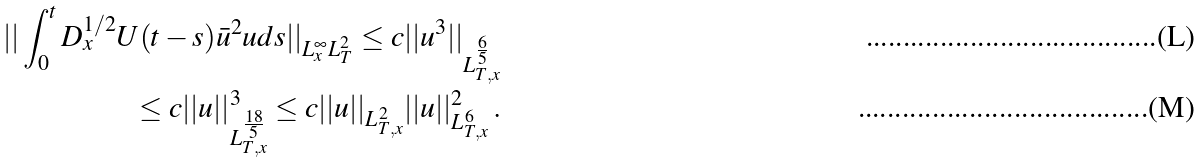<formula> <loc_0><loc_0><loc_500><loc_500>| | \int _ { 0 } ^ { t } D _ { x } ^ { 1 / 2 } U ( t - s ) \bar { u } ^ { 2 } u d s | | _ { L ^ { \infty } _ { x } L ^ { 2 } _ { T } } \leq c | | u ^ { 3 } | | _ { L ^ { \frac { 6 } { 5 } } _ { T , x } } \\ \leq c | | u | | ^ { 3 } _ { L ^ { \frac { 1 8 } { 5 } } _ { T , x } } \leq c | | u | | _ { L ^ { 2 } _ { T , x } } | | u | | ^ { 2 } _ { L ^ { 6 } _ { T , x } } \, .</formula> 